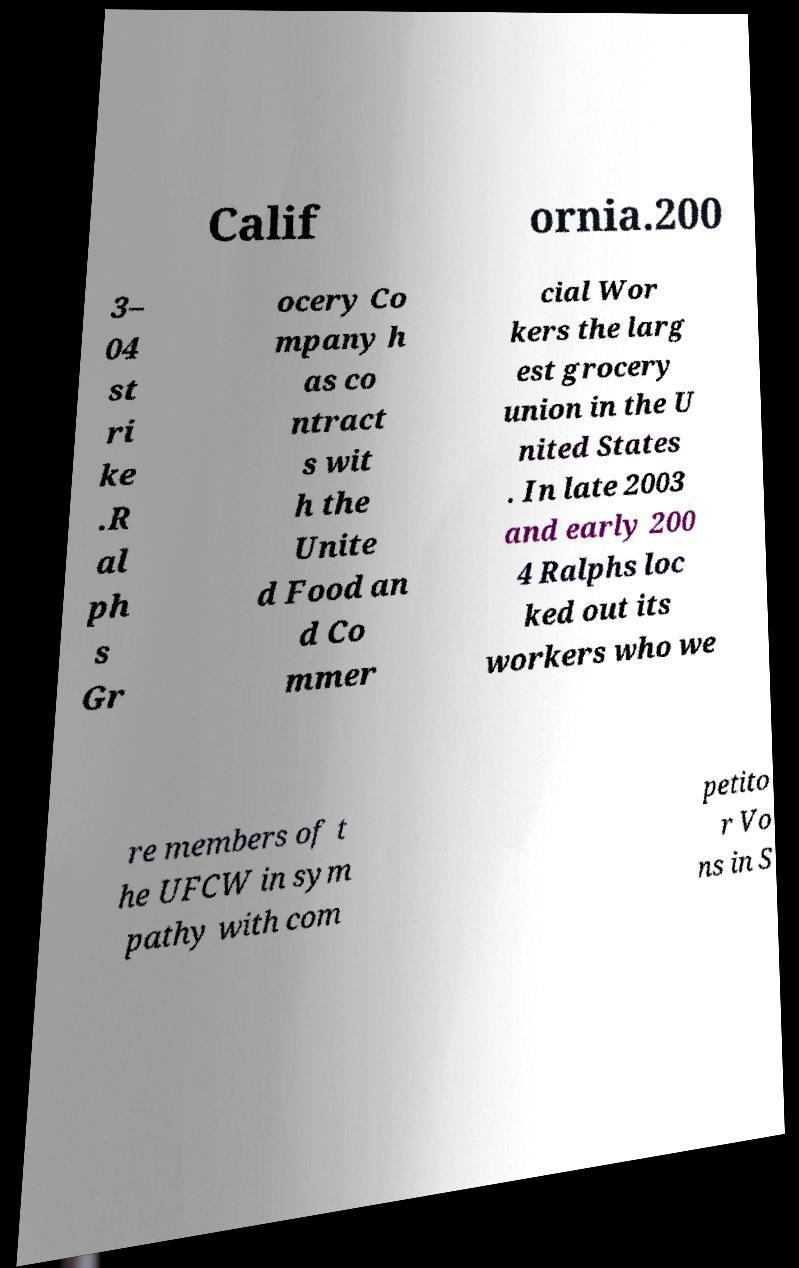Please identify and transcribe the text found in this image. Calif ornia.200 3– 04 st ri ke .R al ph s Gr ocery Co mpany h as co ntract s wit h the Unite d Food an d Co mmer cial Wor kers the larg est grocery union in the U nited States . In late 2003 and early 200 4 Ralphs loc ked out its workers who we re members of t he UFCW in sym pathy with com petito r Vo ns in S 